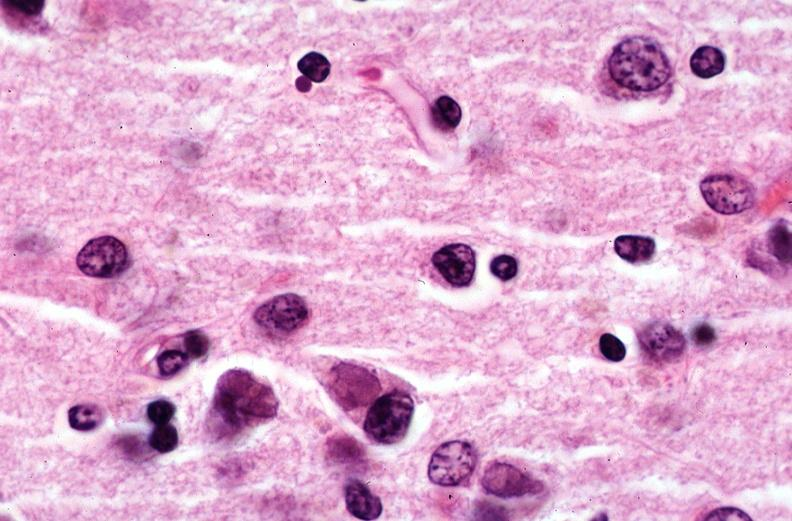s nervous present?
Answer the question using a single word or phrase. Yes 